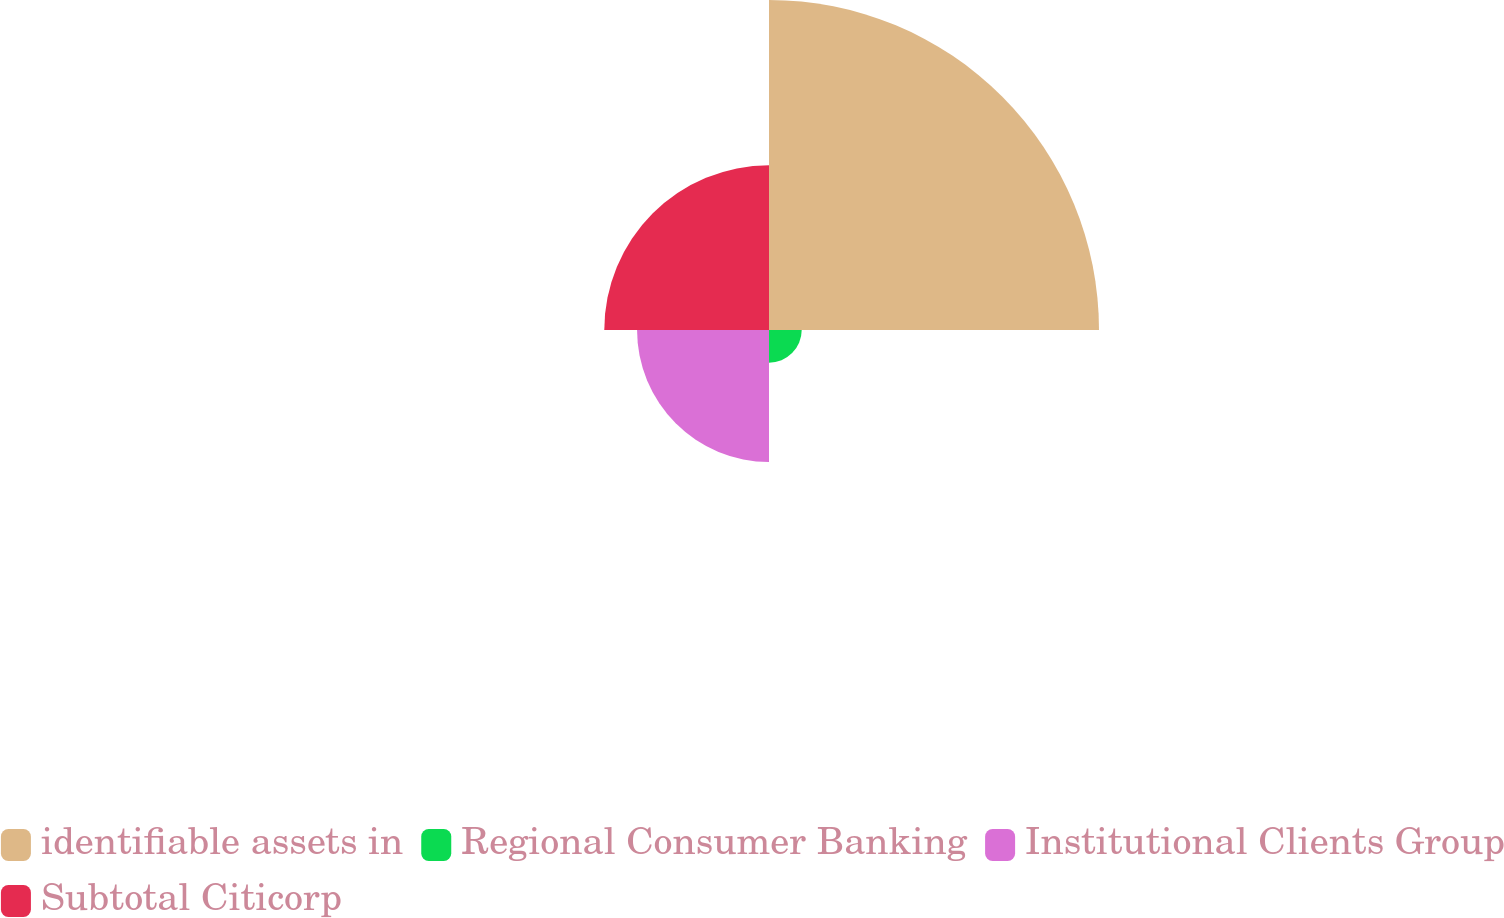Convert chart. <chart><loc_0><loc_0><loc_500><loc_500><pie_chart><fcel>identifiable assets in<fcel>Regional Consumer Banking<fcel>Institutional Clients Group<fcel>Subtotal Citicorp<nl><fcel>50.05%<fcel>4.96%<fcel>20.01%<fcel>24.98%<nl></chart> 